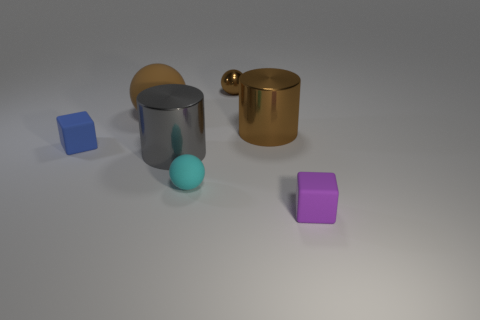Add 2 purple blocks. How many objects exist? 9 Subtract all tiny shiny things. Subtract all cyan matte objects. How many objects are left? 5 Add 2 big spheres. How many big spheres are left? 3 Add 3 small red spheres. How many small red spheres exist? 3 Subtract 0 red balls. How many objects are left? 7 Subtract all blocks. How many objects are left? 5 